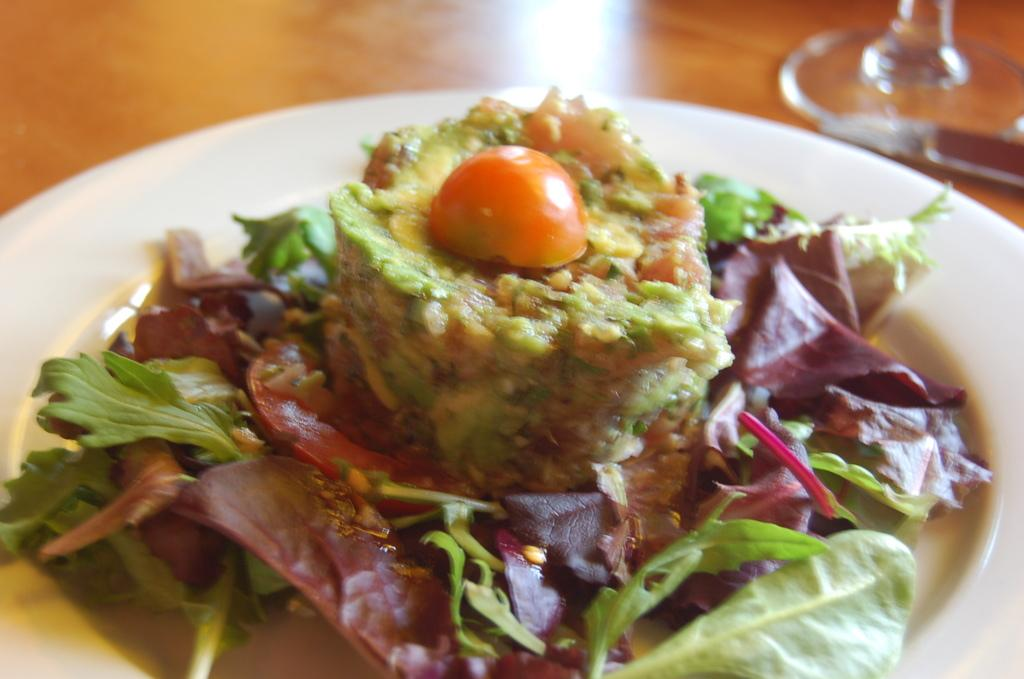What is on the plate that is visible in the image? There is food on a plate in the image. What else can be seen in the image besides the plate of food? There is an object in the image. Where is the table located in the image? There is a table at the bottom of the image. Is the woman in the image wearing a doctor's coat? There is no woman or doctor's coat present in the image. What type of wire can be seen connecting the objects in the image? There is no wire present in the image. 